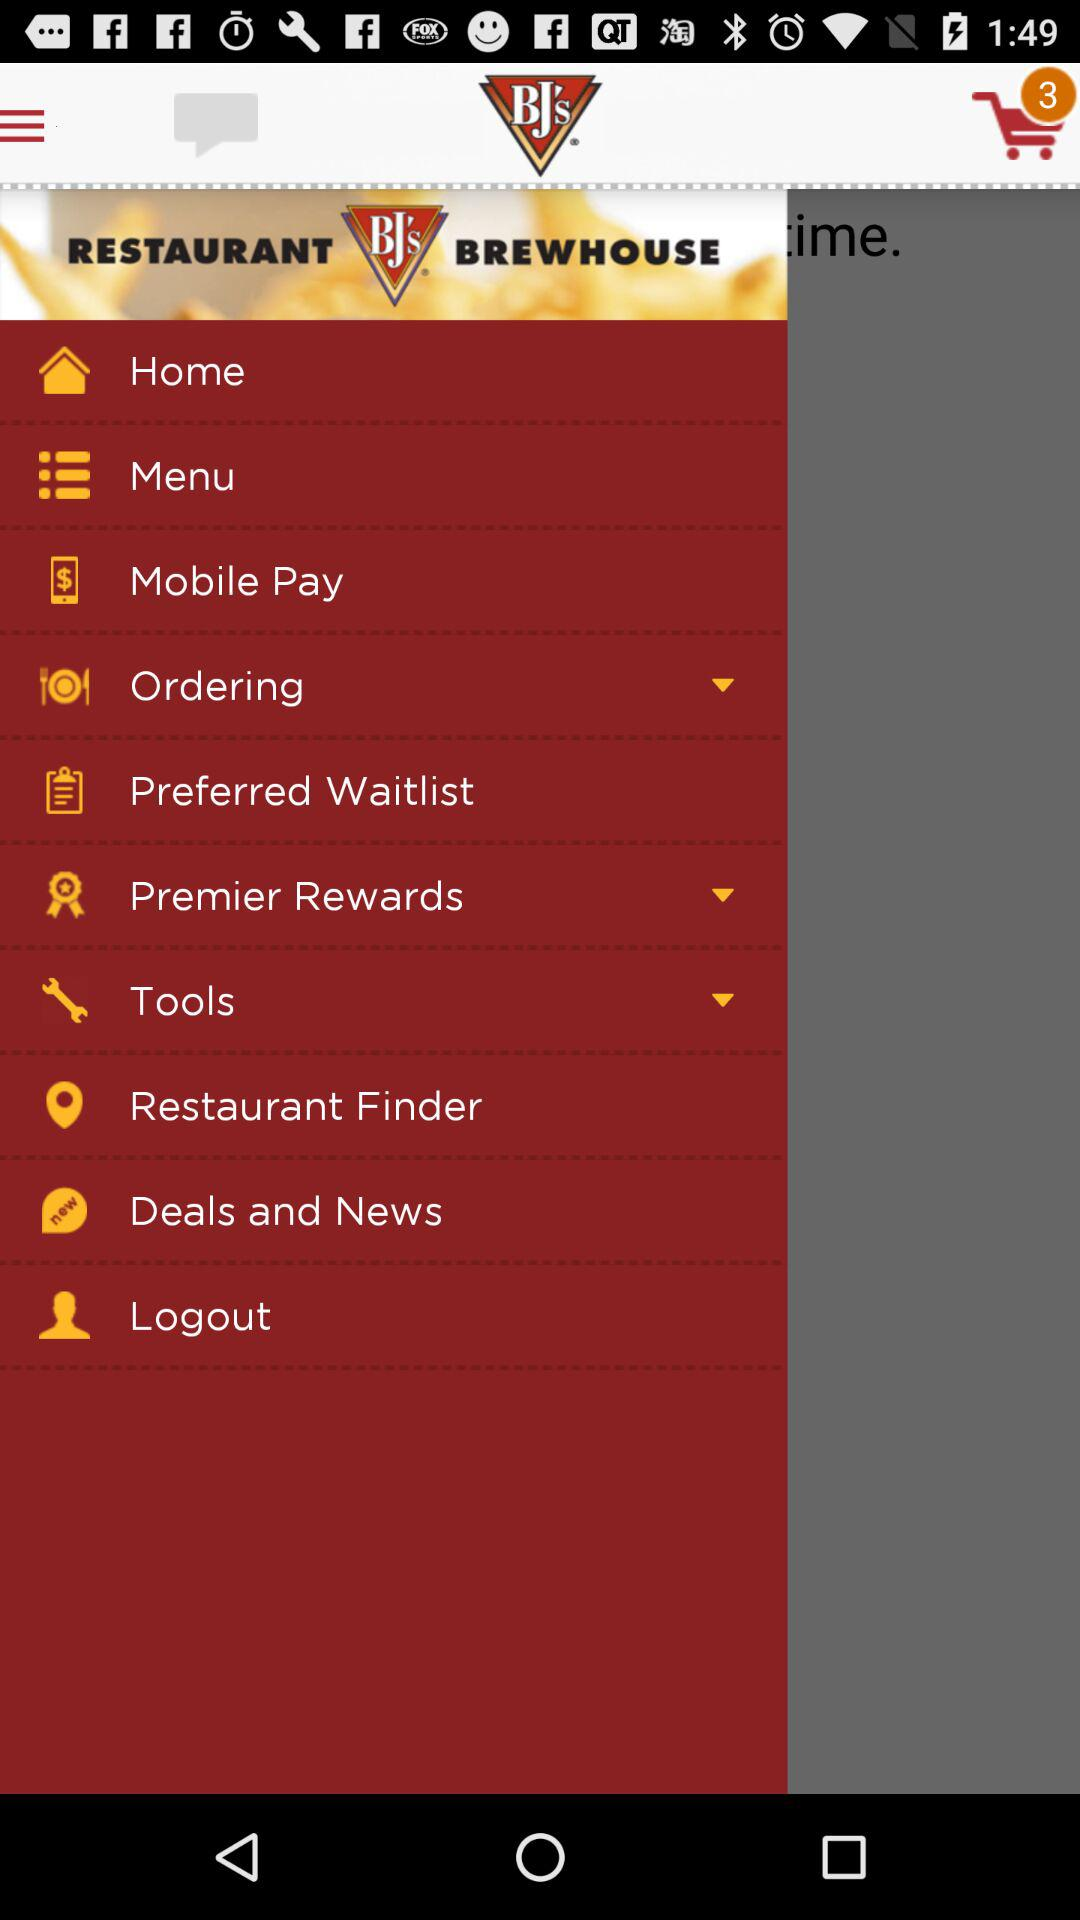What is the application name? The application name is "BJ's". 